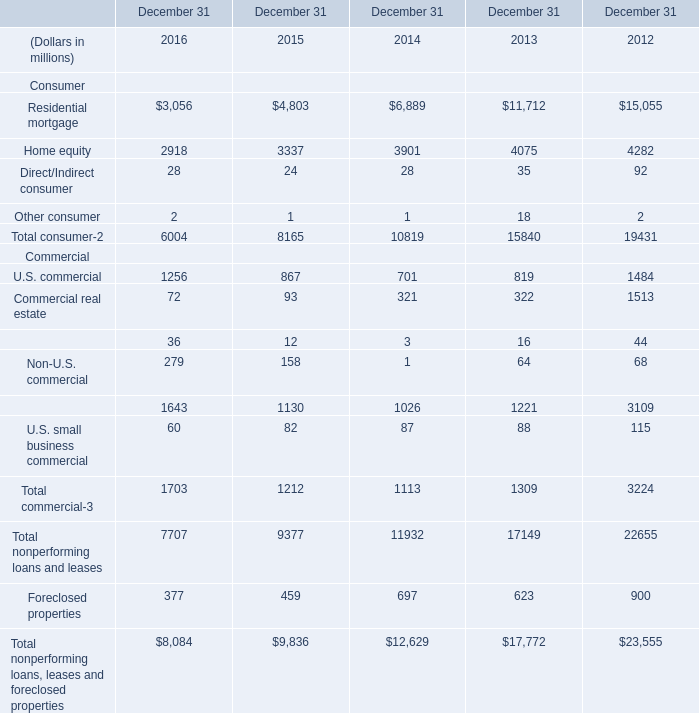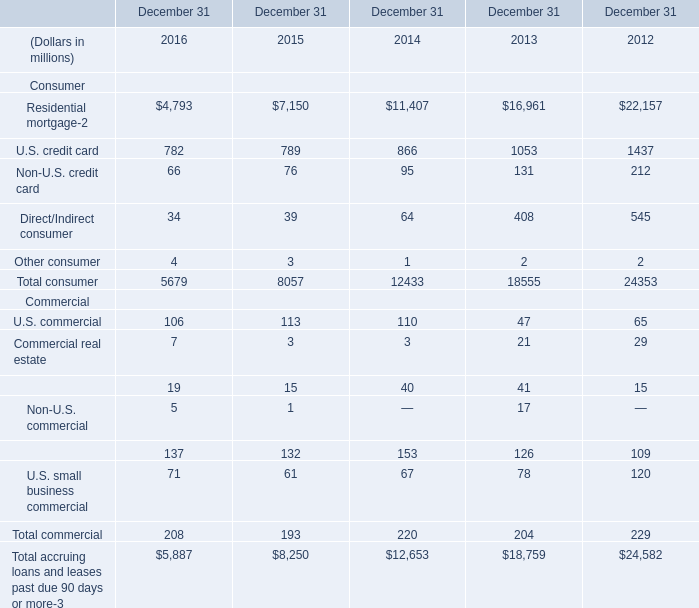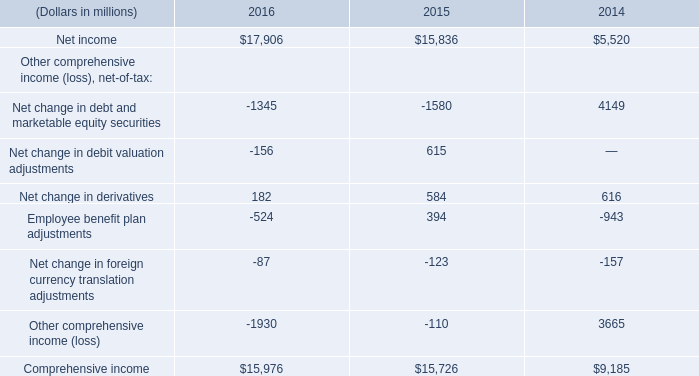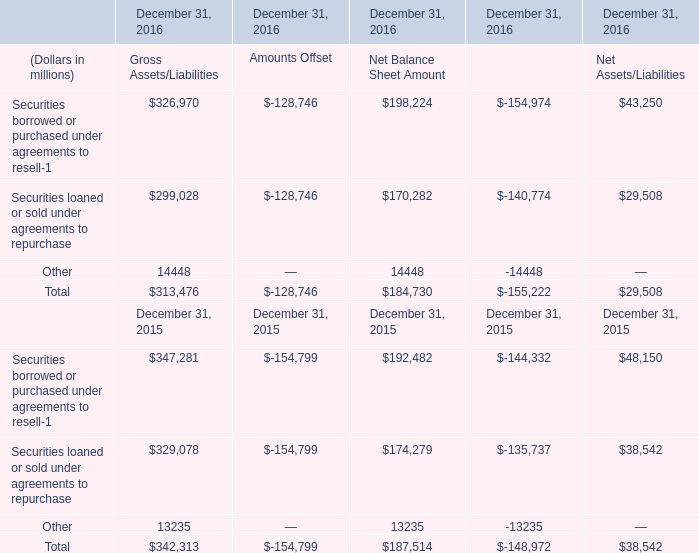What is the average amount of Residential mortgage of December 31 2013, and Residential mortgage of December 31 2014 ? 
Computations: ((16961.0 + 6889.0) / 2)
Answer: 11925.0. 